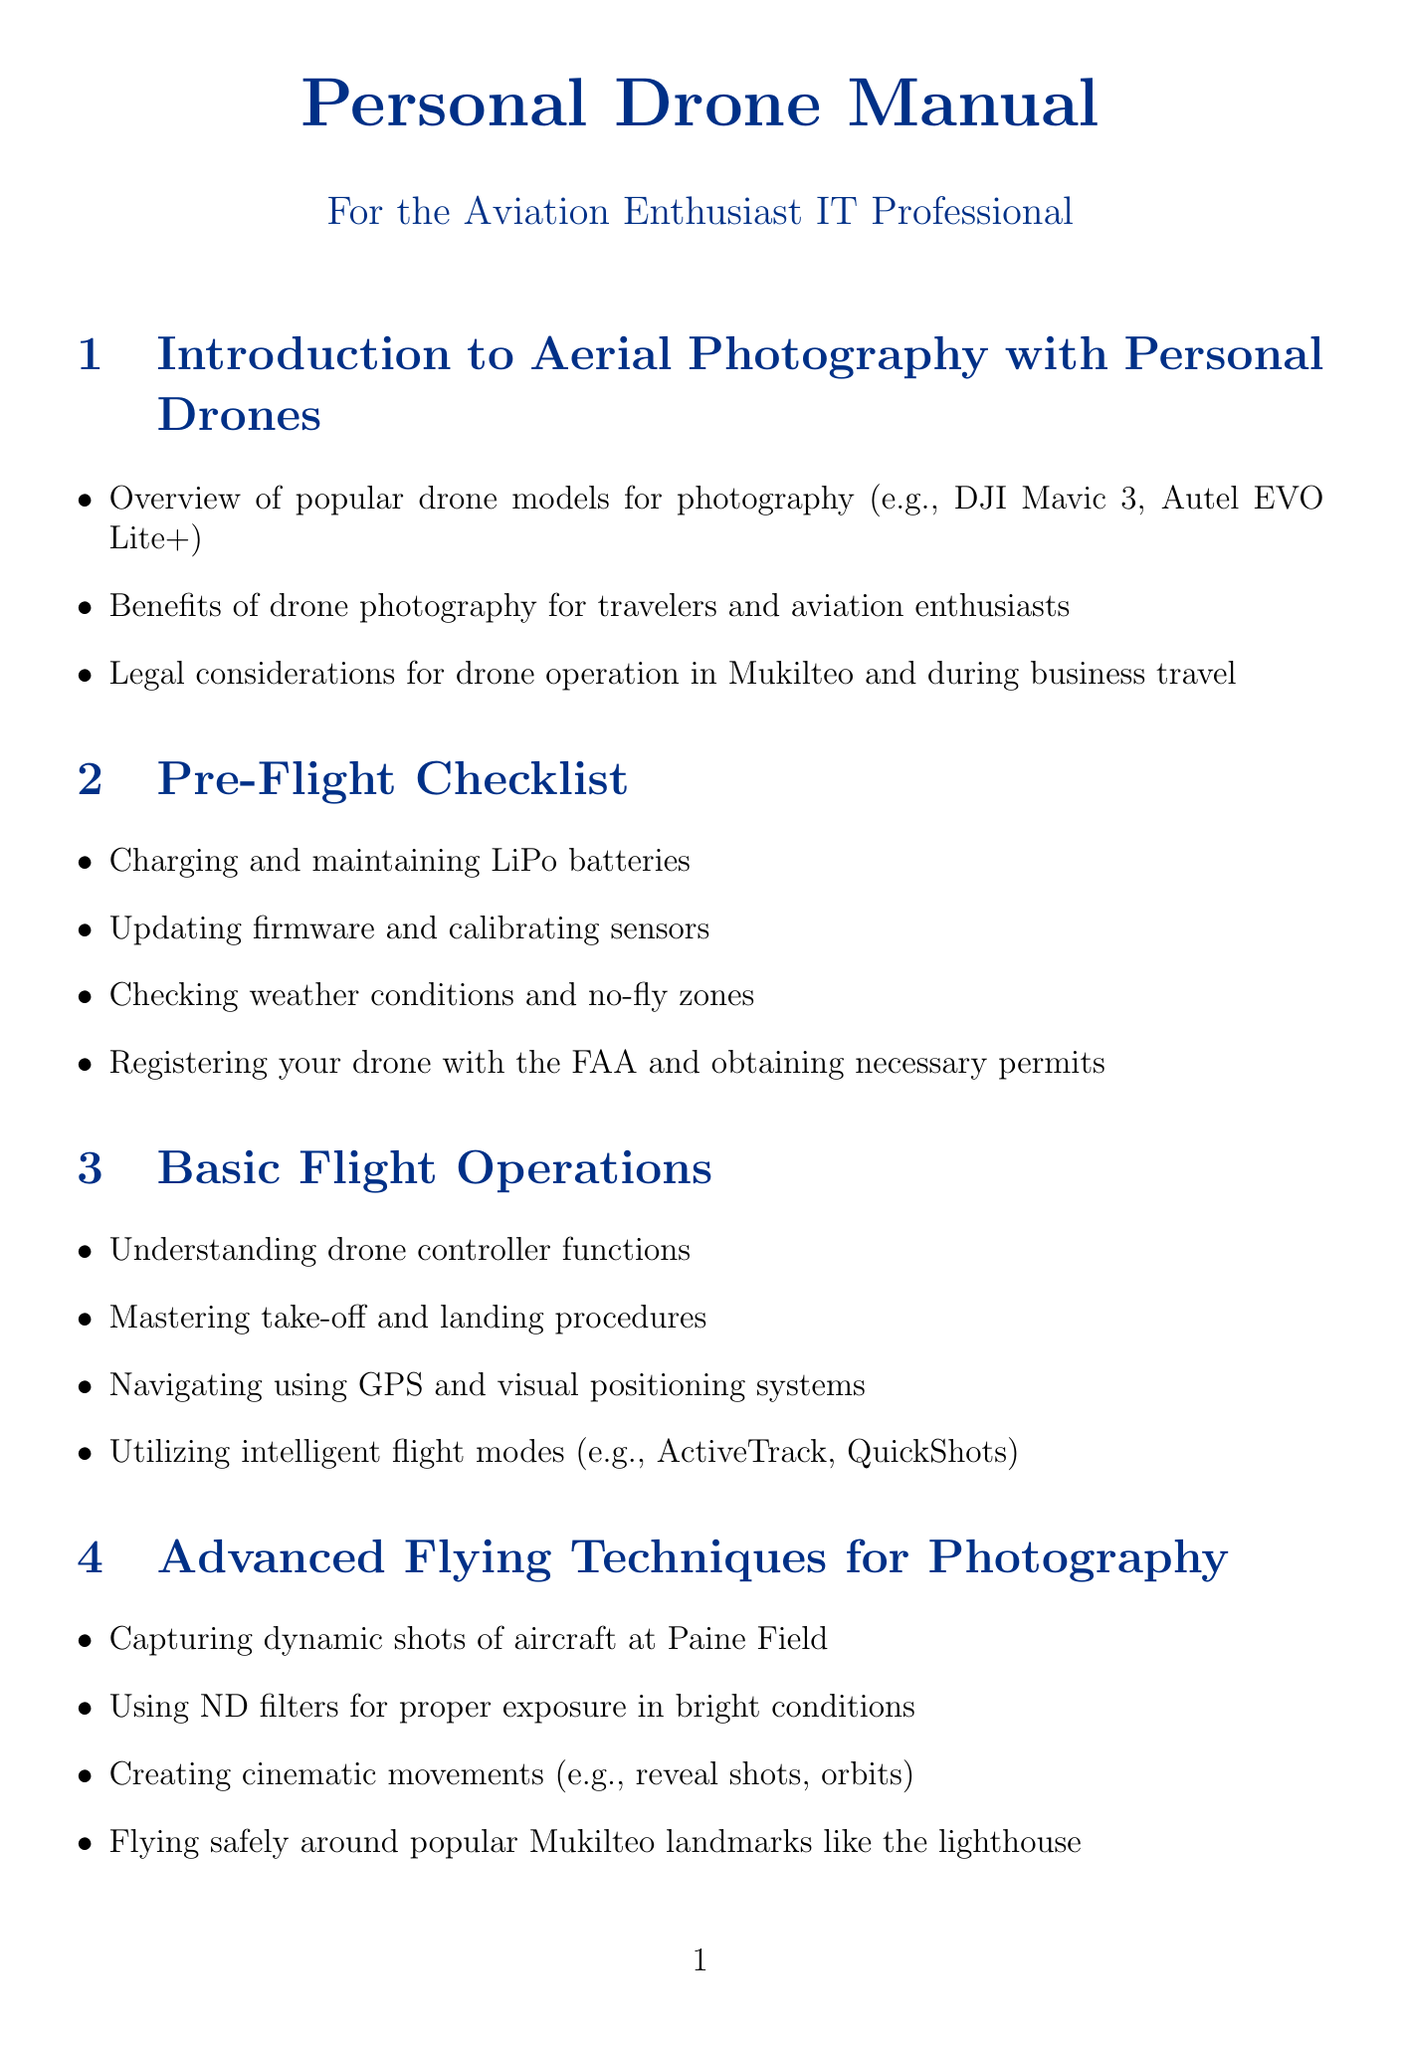What are popular drone models for photography? The document lists popular models such as the DJI Mavic 3 and Autel EVO Lite+.
Answer: DJI Mavic 3, Autel EVO Lite+ Which section covers advanced flying techniques for photography? The section that discusses advanced flying techniques is titled "Advanced Flying Techniques for Photography."
Answer: Advanced Flying Techniques for Photography What should you check in the pre-flight checklist? The pre-flight checklist includes checking weather conditions and no-fly zones, among other items.
Answer: Weather conditions and no-fly zones How can IT professionals utilize drone photography? The document mentions various uses for IT professionals, including capturing aerial footage of data centers and tech campuses.
Answer: Capturing aerial footage of data centers and tech campuses What is one of the safety codes to follow? Following the AMA safety code is highlighted in the document as a key safety guideline.
Answer: AMA safety code What is recommended for protecting equipment while traveling with a drone? The document suggests using proper cases like Pelican or Nanuk to protect drone equipment.
Answer: Proper cases (e.g., Pelican, Nanuk) What type of editing software is mentioned for post-processing? Adobe Lightroom and Premiere Pro are mentioned as software for editing drone footage.
Answer: Adobe Lightroom and Premiere Pro What format is recommended for shooting for maximum editing flexibility? The document recommends shooting in RAW format for optimal editing flexibility.
Answer: RAW format 